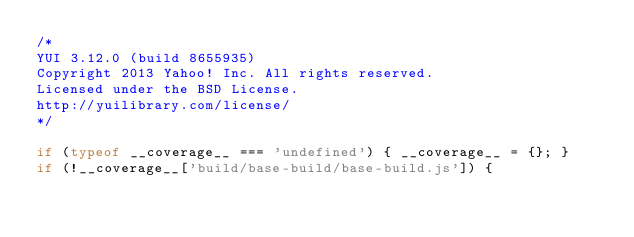<code> <loc_0><loc_0><loc_500><loc_500><_JavaScript_>/*
YUI 3.12.0 (build 8655935)
Copyright 2013 Yahoo! Inc. All rights reserved.
Licensed under the BSD License.
http://yuilibrary.com/license/
*/

if (typeof __coverage__ === 'undefined') { __coverage__ = {}; }
if (!__coverage__['build/base-build/base-build.js']) {</code> 